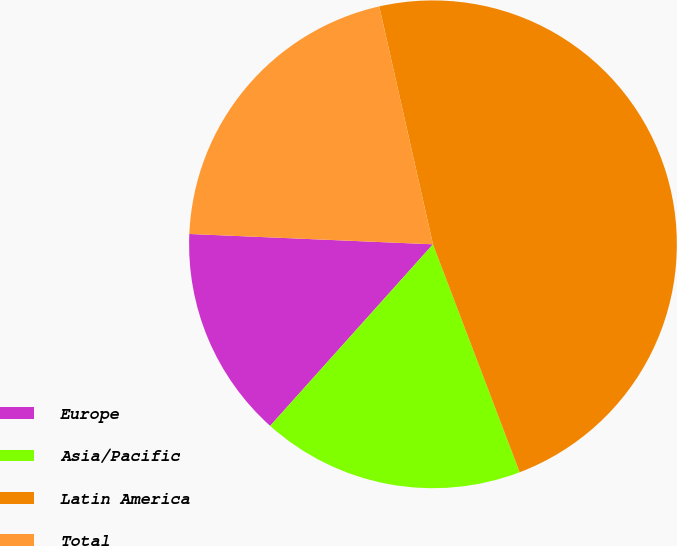Convert chart to OTSL. <chart><loc_0><loc_0><loc_500><loc_500><pie_chart><fcel>Europe<fcel>Asia/Pacific<fcel>Latin America<fcel>Total<nl><fcel>14.04%<fcel>17.42%<fcel>47.75%<fcel>20.79%<nl></chart> 